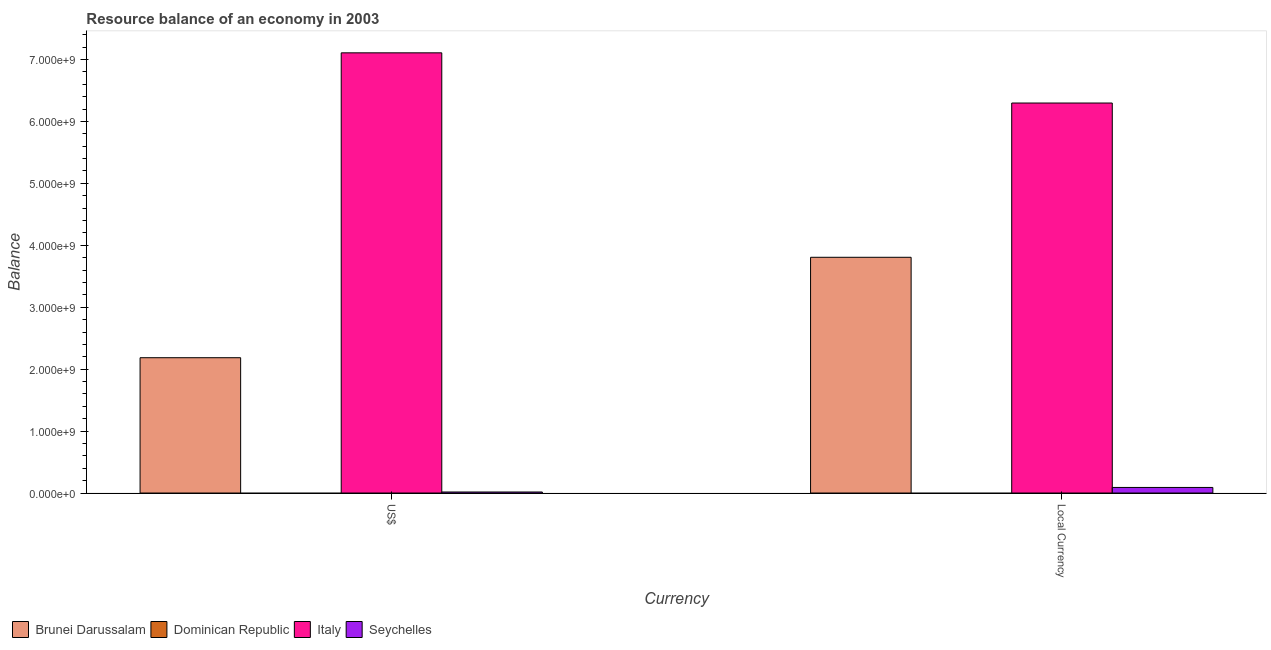How many different coloured bars are there?
Offer a terse response. 3. How many groups of bars are there?
Your answer should be compact. 2. Are the number of bars per tick equal to the number of legend labels?
Ensure brevity in your answer.  No. Are the number of bars on each tick of the X-axis equal?
Give a very brief answer. Yes. How many bars are there on the 2nd tick from the left?
Keep it short and to the point. 3. What is the label of the 1st group of bars from the left?
Ensure brevity in your answer.  US$. What is the resource balance in constant us$ in Dominican Republic?
Ensure brevity in your answer.  0. Across all countries, what is the maximum resource balance in us$?
Offer a very short reply. 7.11e+09. In which country was the resource balance in us$ maximum?
Your answer should be compact. Italy. What is the total resource balance in constant us$ in the graph?
Offer a very short reply. 1.02e+1. What is the difference between the resource balance in us$ in Seychelles and that in Brunei Darussalam?
Offer a very short reply. -2.17e+09. What is the difference between the resource balance in us$ in Seychelles and the resource balance in constant us$ in Italy?
Keep it short and to the point. -6.28e+09. What is the average resource balance in us$ per country?
Make the answer very short. 2.33e+09. What is the difference between the resource balance in constant us$ and resource balance in us$ in Seychelles?
Make the answer very short. 7.35e+07. What is the ratio of the resource balance in us$ in Seychelles to that in Brunei Darussalam?
Your answer should be very brief. 0.01. In how many countries, is the resource balance in constant us$ greater than the average resource balance in constant us$ taken over all countries?
Keep it short and to the point. 2. Are all the bars in the graph horizontal?
Offer a very short reply. No. Are the values on the major ticks of Y-axis written in scientific E-notation?
Offer a terse response. Yes. Does the graph contain any zero values?
Your answer should be very brief. Yes. Where does the legend appear in the graph?
Provide a succinct answer. Bottom left. How are the legend labels stacked?
Offer a terse response. Horizontal. What is the title of the graph?
Your answer should be very brief. Resource balance of an economy in 2003. What is the label or title of the X-axis?
Make the answer very short. Currency. What is the label or title of the Y-axis?
Offer a terse response. Balance. What is the Balance in Brunei Darussalam in US$?
Ensure brevity in your answer.  2.18e+09. What is the Balance of Italy in US$?
Provide a succinct answer. 7.11e+09. What is the Balance in Seychelles in US$?
Offer a terse response. 1.67e+07. What is the Balance of Brunei Darussalam in Local Currency?
Your response must be concise. 3.81e+09. What is the Balance of Dominican Republic in Local Currency?
Offer a terse response. 0. What is the Balance in Italy in Local Currency?
Make the answer very short. 6.30e+09. What is the Balance in Seychelles in Local Currency?
Make the answer very short. 9.02e+07. Across all Currency, what is the maximum Balance in Brunei Darussalam?
Offer a very short reply. 3.81e+09. Across all Currency, what is the maximum Balance in Italy?
Give a very brief answer. 7.11e+09. Across all Currency, what is the maximum Balance of Seychelles?
Make the answer very short. 9.02e+07. Across all Currency, what is the minimum Balance in Brunei Darussalam?
Your answer should be very brief. 2.18e+09. Across all Currency, what is the minimum Balance of Italy?
Provide a short and direct response. 6.30e+09. Across all Currency, what is the minimum Balance in Seychelles?
Ensure brevity in your answer.  1.67e+07. What is the total Balance of Brunei Darussalam in the graph?
Keep it short and to the point. 5.99e+09. What is the total Balance of Dominican Republic in the graph?
Offer a very short reply. 0. What is the total Balance in Italy in the graph?
Your response must be concise. 1.34e+1. What is the total Balance of Seychelles in the graph?
Keep it short and to the point. 1.07e+08. What is the difference between the Balance of Brunei Darussalam in US$ and that in Local Currency?
Provide a short and direct response. -1.62e+09. What is the difference between the Balance of Italy in US$ and that in Local Currency?
Offer a very short reply. 8.10e+08. What is the difference between the Balance in Seychelles in US$ and that in Local Currency?
Offer a very short reply. -7.35e+07. What is the difference between the Balance of Brunei Darussalam in US$ and the Balance of Italy in Local Currency?
Provide a succinct answer. -4.11e+09. What is the difference between the Balance of Brunei Darussalam in US$ and the Balance of Seychelles in Local Currency?
Your response must be concise. 2.09e+09. What is the difference between the Balance of Italy in US$ and the Balance of Seychelles in Local Currency?
Your response must be concise. 7.02e+09. What is the average Balance of Brunei Darussalam per Currency?
Ensure brevity in your answer.  3.00e+09. What is the average Balance of Italy per Currency?
Provide a short and direct response. 6.70e+09. What is the average Balance in Seychelles per Currency?
Give a very brief answer. 5.34e+07. What is the difference between the Balance of Brunei Darussalam and Balance of Italy in US$?
Your response must be concise. -4.92e+09. What is the difference between the Balance of Brunei Darussalam and Balance of Seychelles in US$?
Make the answer very short. 2.17e+09. What is the difference between the Balance of Italy and Balance of Seychelles in US$?
Ensure brevity in your answer.  7.09e+09. What is the difference between the Balance in Brunei Darussalam and Balance in Italy in Local Currency?
Your answer should be very brief. -2.49e+09. What is the difference between the Balance in Brunei Darussalam and Balance in Seychelles in Local Currency?
Your answer should be compact. 3.72e+09. What is the difference between the Balance of Italy and Balance of Seychelles in Local Currency?
Make the answer very short. 6.21e+09. What is the ratio of the Balance of Brunei Darussalam in US$ to that in Local Currency?
Your answer should be compact. 0.57. What is the ratio of the Balance of Italy in US$ to that in Local Currency?
Keep it short and to the point. 1.13. What is the ratio of the Balance in Seychelles in US$ to that in Local Currency?
Keep it short and to the point. 0.19. What is the difference between the highest and the second highest Balance of Brunei Darussalam?
Provide a succinct answer. 1.62e+09. What is the difference between the highest and the second highest Balance of Italy?
Give a very brief answer. 8.10e+08. What is the difference between the highest and the second highest Balance of Seychelles?
Provide a succinct answer. 7.35e+07. What is the difference between the highest and the lowest Balance in Brunei Darussalam?
Make the answer very short. 1.62e+09. What is the difference between the highest and the lowest Balance of Italy?
Keep it short and to the point. 8.10e+08. What is the difference between the highest and the lowest Balance of Seychelles?
Keep it short and to the point. 7.35e+07. 